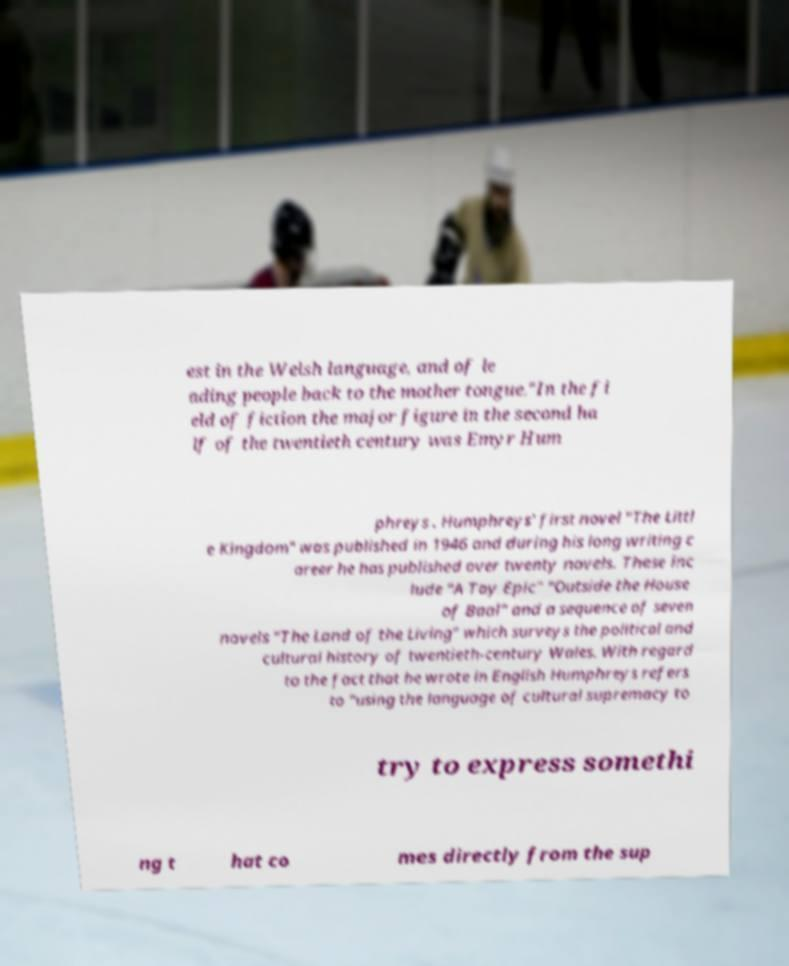What messages or text are displayed in this image? I need them in a readable, typed format. est in the Welsh language, and of le ading people back to the mother tongue."In the fi eld of fiction the major figure in the second ha lf of the twentieth century was Emyr Hum phreys . Humphreys' first novel "The Littl e Kingdom" was published in 1946 and during his long writing c areer he has published over twenty novels. These inc lude "A Toy Epic" "Outside the House of Baal" and a sequence of seven novels "The Land of the Living" which surveys the political and cultural history of twentieth-century Wales. With regard to the fact that he wrote in English Humphreys refers to "using the language of cultural supremacy to try to express somethi ng t hat co mes directly from the sup 